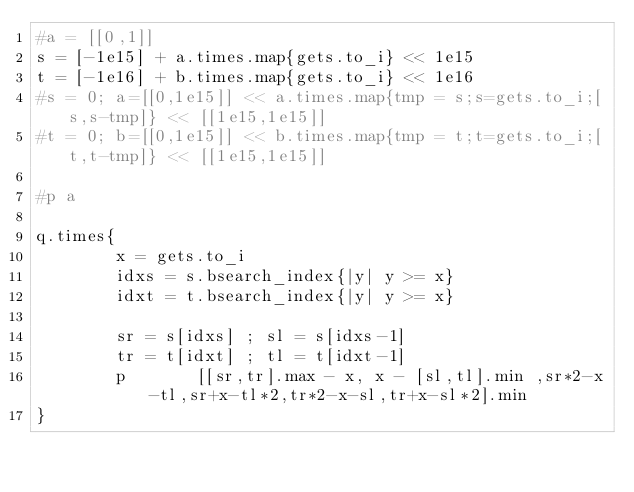<code> <loc_0><loc_0><loc_500><loc_500><_Ruby_>#a = [[0,1]]
s = [-1e15] + a.times.map{gets.to_i} << 1e15
t = [-1e16] + b.times.map{gets.to_i} << 1e16
#s = 0; a=[[0,1e15]] << a.times.map{tmp = s;s=gets.to_i;[s,s-tmp]} << [[1e15,1e15]]
#t = 0; b=[[0,1e15]] << b.times.map{tmp = t;t=gets.to_i;[t,t-tmp]} << [[1e15,1e15]]

#p a

q.times{
        x = gets.to_i
        idxs = s.bsearch_index{|y| y >= x}
        idxt = t.bsearch_index{|y| y >= x}

        sr = s[idxs] ; sl = s[idxs-1]
        tr = t[idxt] ; tl = t[idxt-1]
        p       [[sr,tr].max - x, x - [sl,tl].min ,sr*2-x-tl,sr+x-tl*2,tr*2-x-sl,tr+x-sl*2].min
}
</code> 